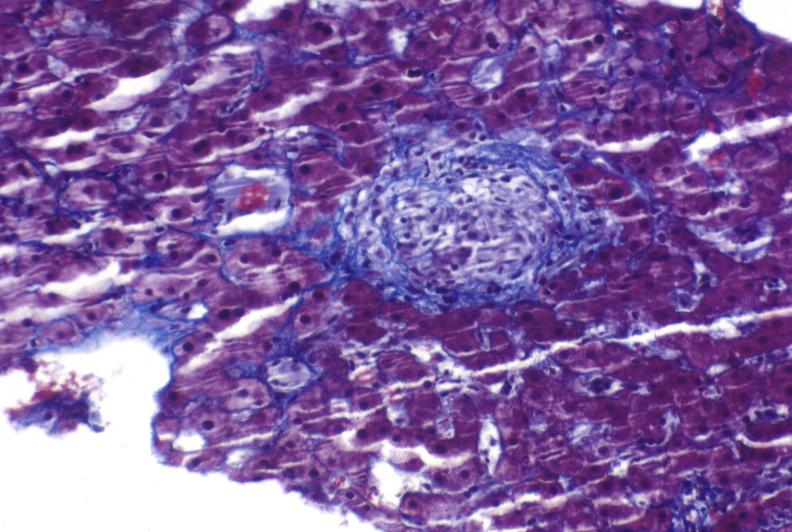s hepatobiliary present?
Answer the question using a single word or phrase. Yes 